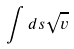<formula> <loc_0><loc_0><loc_500><loc_500>\int d s \sqrt { v }</formula> 